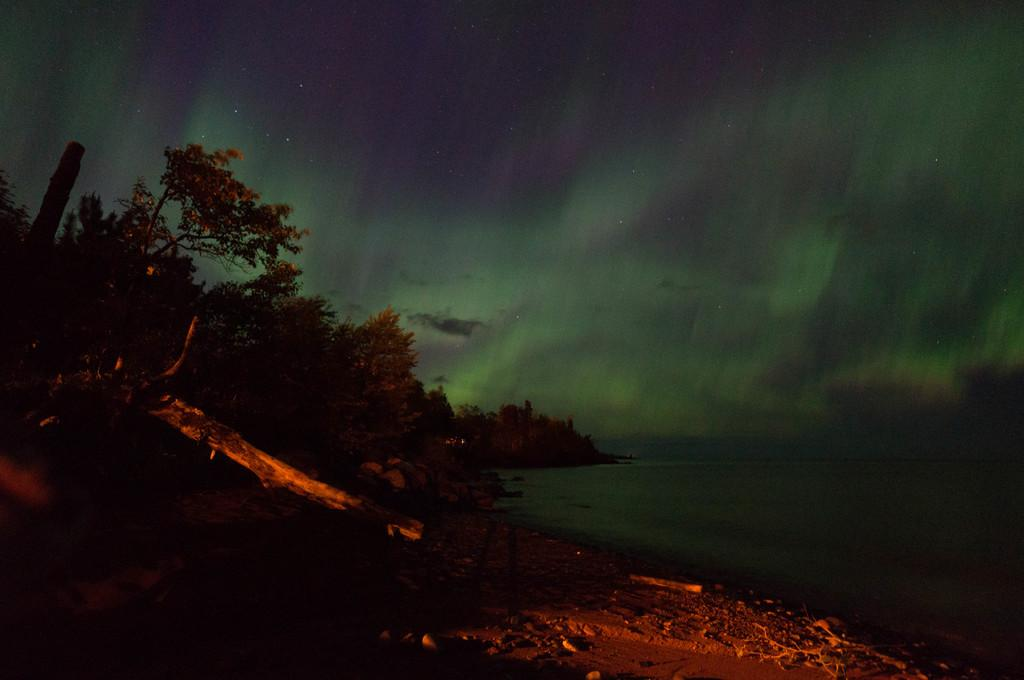What type of vegetation can be seen in the image? There are trees in the image. What natural element is visible besides the trees? There is water visible in the image. What can be seen in the background of the image? The sky is visible in the background of the image. What type of friction can be observed between the trees and the river in the image? There is no river present in the image, and therefore no friction between the trees and a river can be observed. 